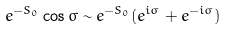<formula> <loc_0><loc_0><loc_500><loc_500>e ^ { - S _ { 0 } } \cos \sigma \sim e ^ { - S _ { 0 } } ( e ^ { i \sigma } + e ^ { - i \sigma } )</formula> 